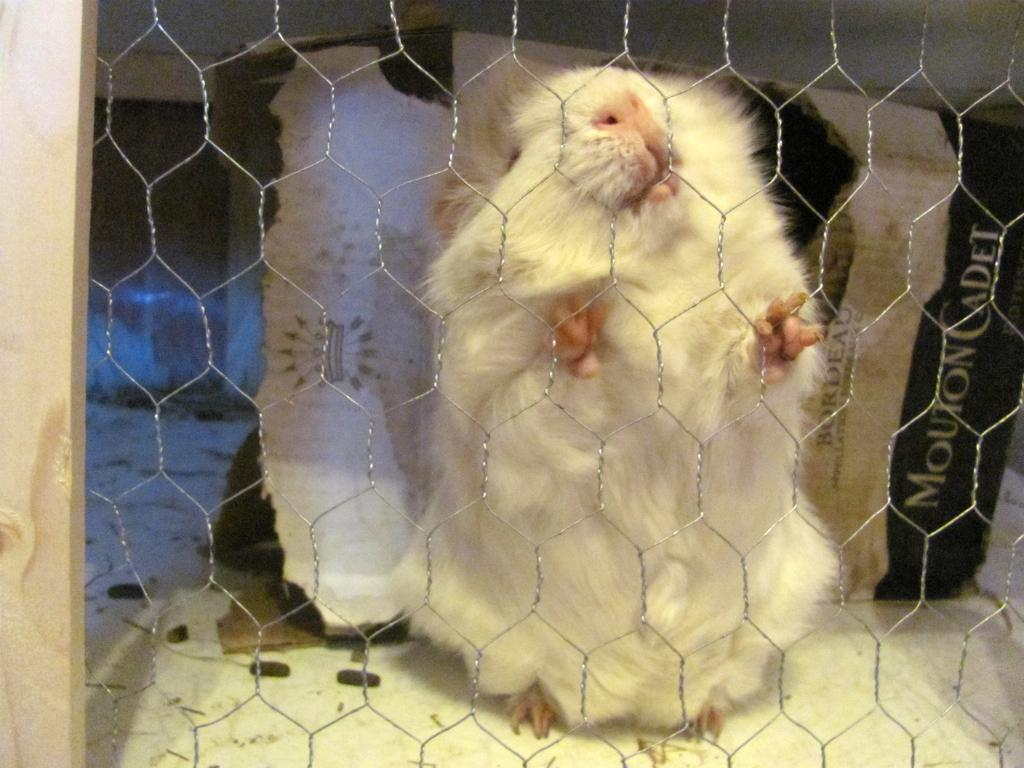What animal is present in the image? There is a rat in the image. Where is the rat located? The rat is inside a cage. What is the material of the cage's frame? The cage has a wooden frame. What can be seen in the background of the image? There is a cardboard in the background of the image. What type of bird is fighting with the rat in the image? There is no bird present in the image, nor is there any fighting taking place. 